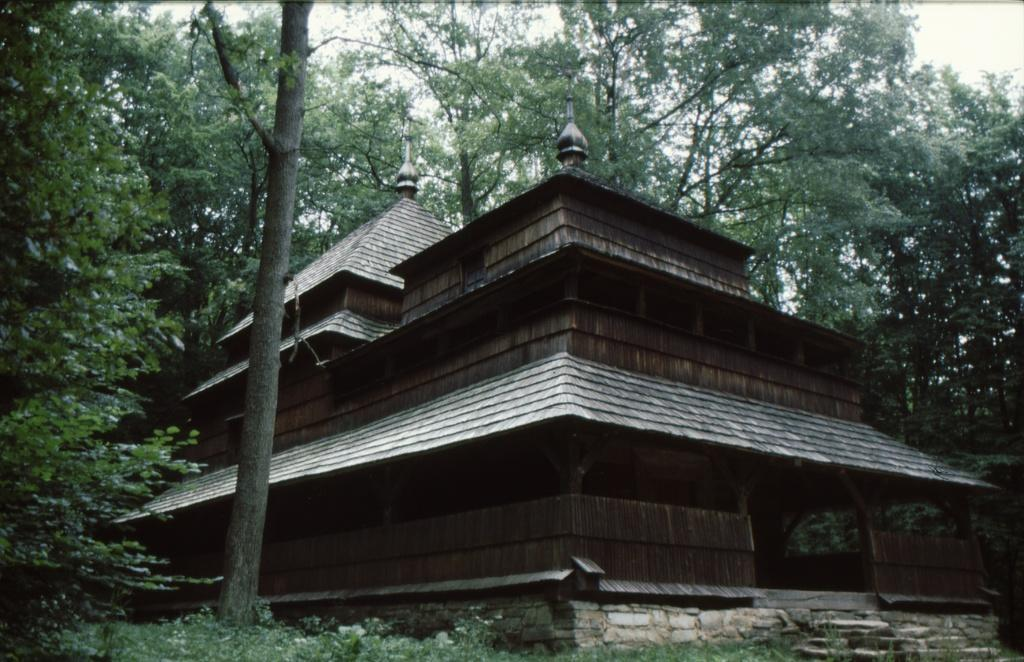What type of house is in the image? There is a wooden house in the image. What other natural elements can be seen in the image? There are trees in the image. What is visible at the top of the image? The sky is visible at the top of the image. What type of ground is present at the bottom of the image? Grass is present at the bottom of the image. What is the price of the net used to catch the animals in the image? There is no net or animals present in the image, so it is not possible to determine the price of a net. 